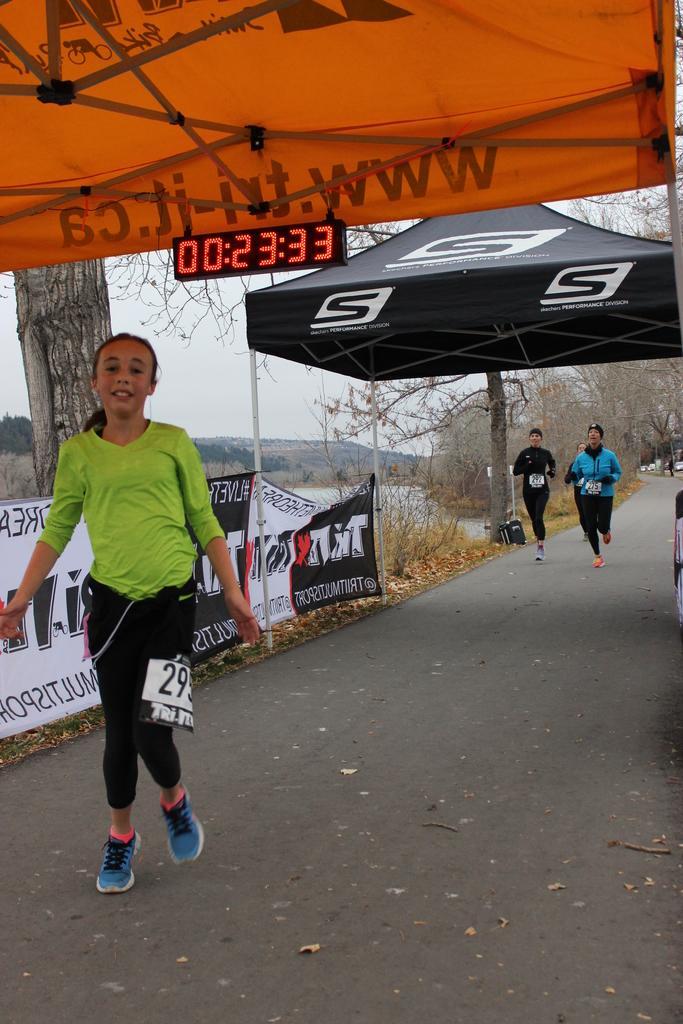Describe this image in one or two sentences. This picture is clicked outside. On the left we can see a person wearing t-shirt and seems to be running. In the background we can see the group of persons running on the ground and we can see the text on the banners and we can see the tents and the numbers on the digital screen. In the background we can see the sky, trees, plants, metal rods and some other objects and we can see the text on the tents. 